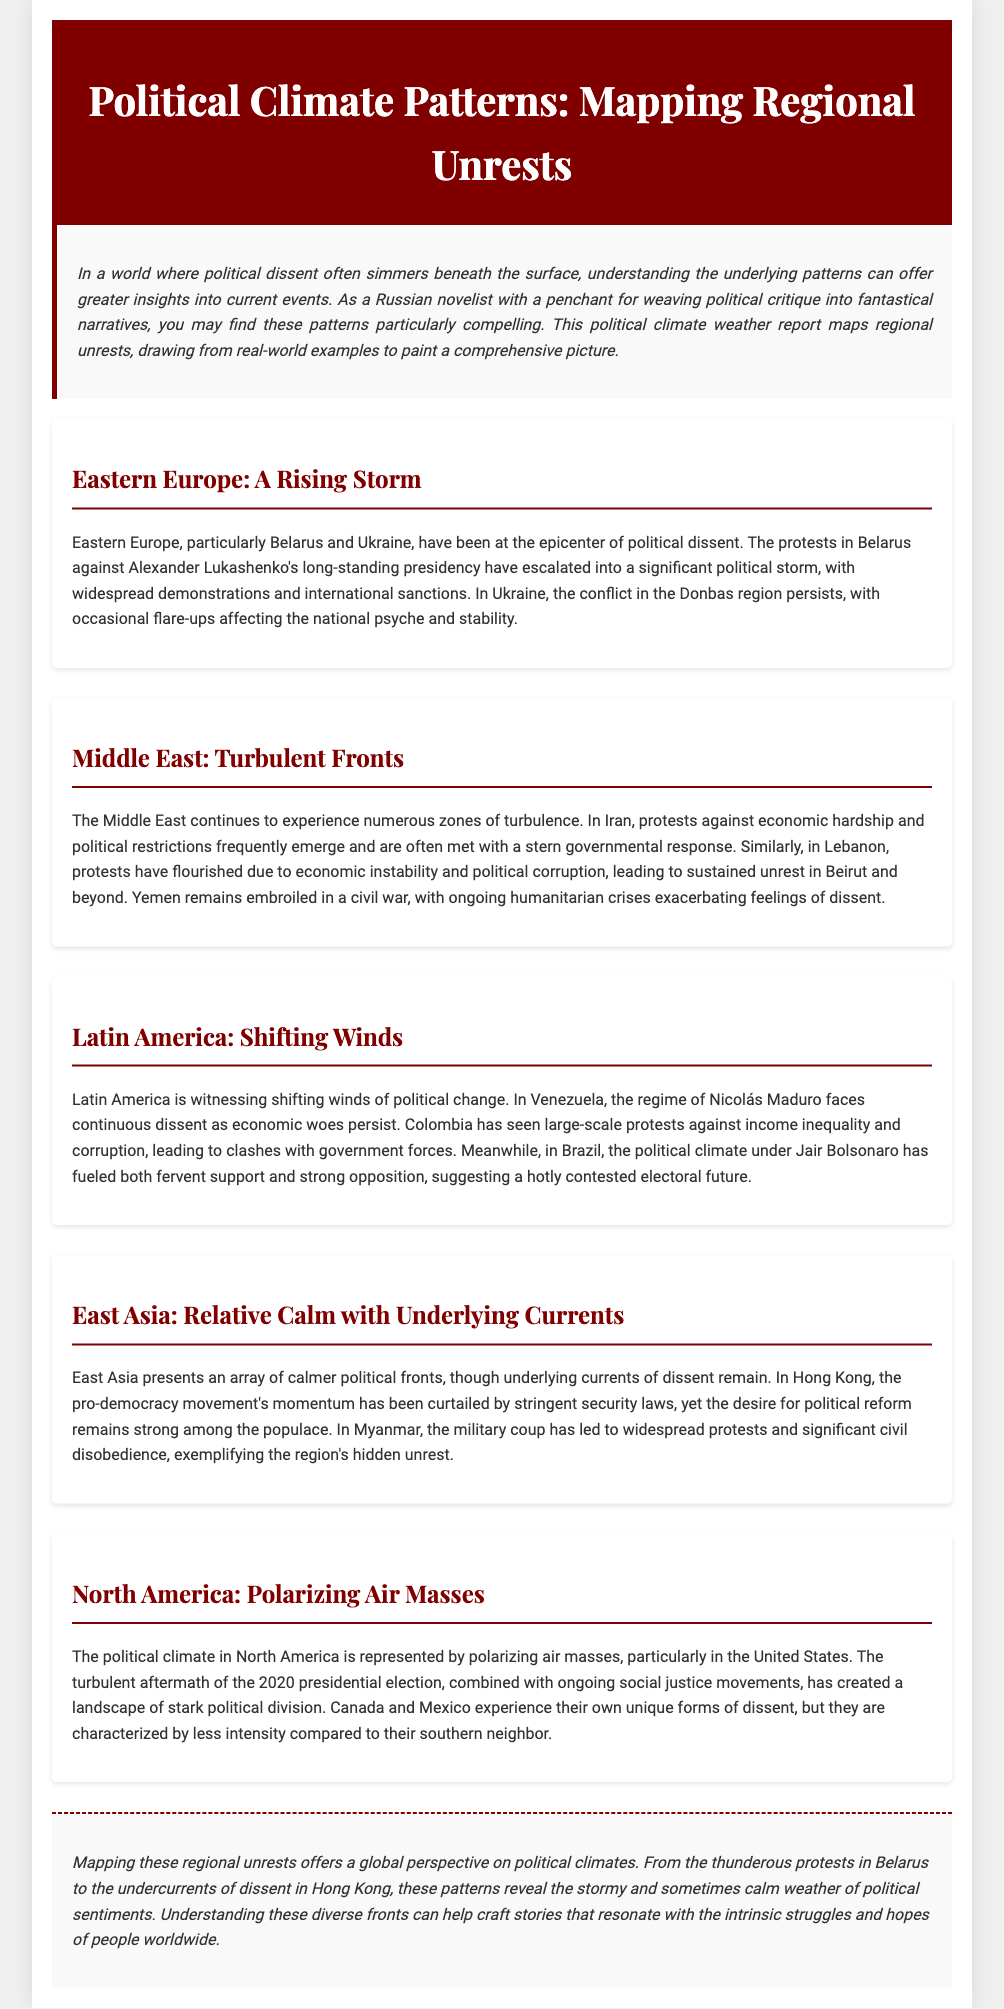What are the two key regions discussed in the Eastern Europe section? The document highlights Belarus and Ukraine as key regions facing political dissent in Eastern Europe.
Answer: Belarus, Ukraine Which country is experiencing protests against economic hardship and political restrictions? Iran is mentioned in the Middle East section as facing protests due to economic hardship and political restrictions.
Answer: Iran What significant political event is occurring in Myanmar? The section covering East Asia indicates that Myanmar is experiencing a military coup leading to widespread protests and civil disobedience.
Answer: Military coup What type of unrest is escalating in Venezuela? The document states that Venezuela is facing continuous dissent against Nicolás Maduro's regime due to economic woes.
Answer: Continuous dissent Which political leader is associated with strong opposition in Brazil? The text mentions Jair Bolsonaro in relation to a divisive political climate in Brazil, indicating both strong support and opposition.
Answer: Jair Bolsonaro What is the overarching theme of the document? The report seeks to map and understand patterns of political unrest globally, portraying a weather report metaphorically related to political climates.
Answer: Political unrest patterns How does the situation in Hong Kong differ from Myanmar? In Hong Kong, the pro-democracy movement struggles under new laws, while Myanmar is under military coup with protests.
Answer: Pro-democracy movement, military coup What common feature is noted in the political climates of North America? The document suggests that North America is characterized by polarizing air masses due to political division, especially in the U.S.
Answer: Polarizing air masses 